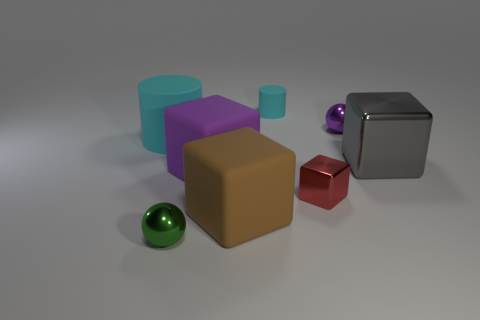Subtract all gray metallic blocks. How many blocks are left? 3 Add 1 tiny brown metal cylinders. How many objects exist? 9 Subtract all gray cubes. How many cubes are left? 3 Subtract all cylinders. How many objects are left? 6 Subtract 2 balls. How many balls are left? 0 Subtract all big gray blocks. Subtract all large gray metal things. How many objects are left? 6 Add 3 purple blocks. How many purple blocks are left? 4 Add 8 purple metallic cylinders. How many purple metallic cylinders exist? 8 Subtract 0 gray cylinders. How many objects are left? 8 Subtract all cyan spheres. Subtract all red cylinders. How many spheres are left? 2 